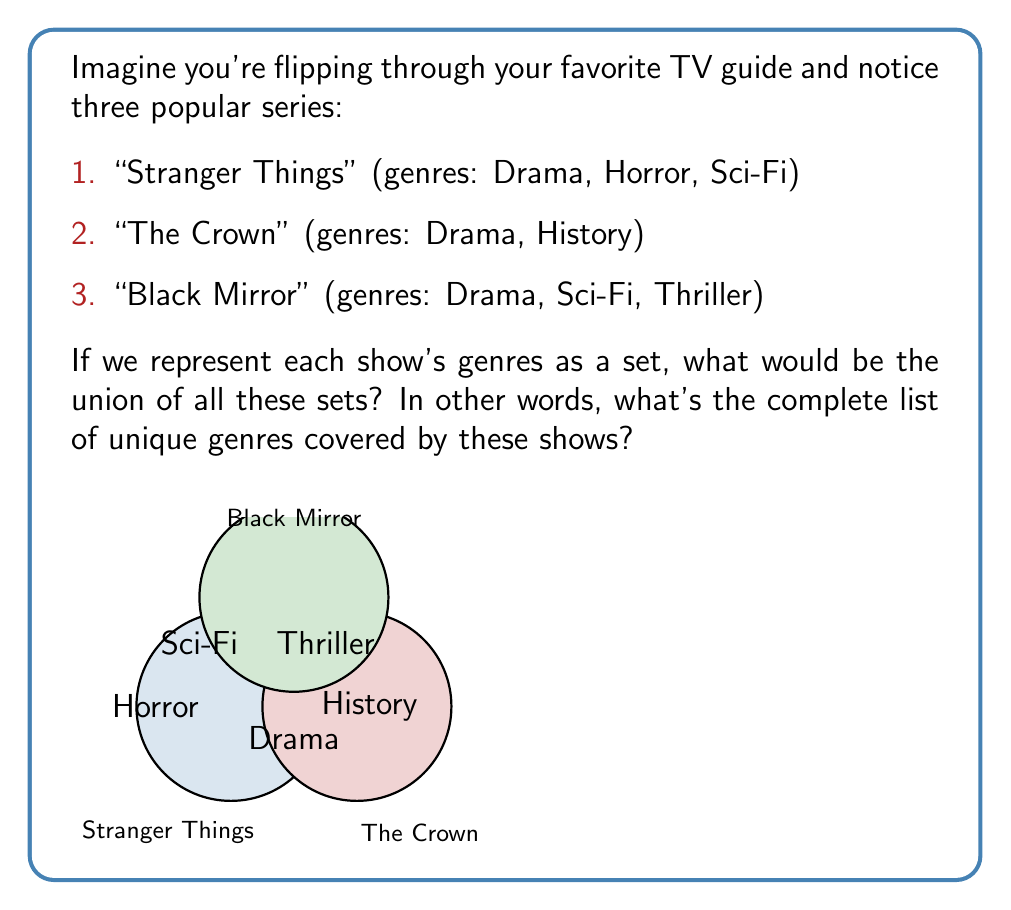Provide a solution to this math problem. Let's approach this step-by-step:

1) First, let's define our sets:
   
   $A = \{\text{Drama, Horror, Sci-Fi}\}$ (Stranger Things)
   $B = \{\text{Drama, History}\}$ (The Crown)
   $C = \{\text{Drama, Sci-Fi, Thriller}\}$ (Black Mirror)

2) We need to find the union of these sets, which we can write as $A \cup B \cup C$.

3) The union of sets includes all unique elements from all sets. In other words, we list each genre that appears in at least one of the sets, but we only list it once even if it appears in multiple sets.

4) Let's start with set $A$ and add new elements as we go:
   - From $A$: Drama, Horror, Sci-Fi
   - From $B$: History (Drama is already included)
   - From $C$: Thriller (Drama and Sci-Fi are already included)

5) Therefore, the union of all sets is:

   $A \cup B \cup C = \{\text{Drama, Horror, Sci-Fi, History, Thriller}\}$

This gives us the complete list of unique genres covered by these shows.
Answer: $\{\text{Drama, Horror, Sci-Fi, History, Thriller}\}$ 